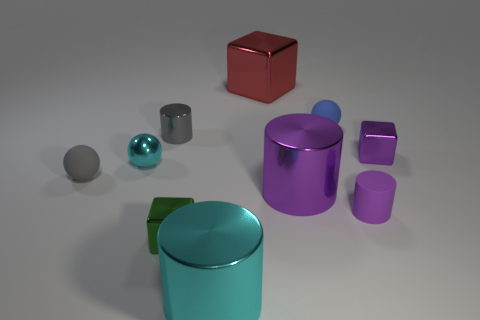Subtract all large blocks. How many blocks are left? 2 Subtract all blue balls. How many purple cylinders are left? 2 Subtract 2 cylinders. How many cylinders are left? 2 Subtract all cyan spheres. How many spheres are left? 2 Subtract all balls. How many objects are left? 7 Subtract all brown balls. Subtract all brown blocks. How many balls are left? 3 Add 5 big things. How many big things are left? 8 Add 4 large red spheres. How many large red spheres exist? 4 Subtract 0 yellow balls. How many objects are left? 10 Subtract all blue cylinders. Subtract all tiny cyan metal spheres. How many objects are left? 9 